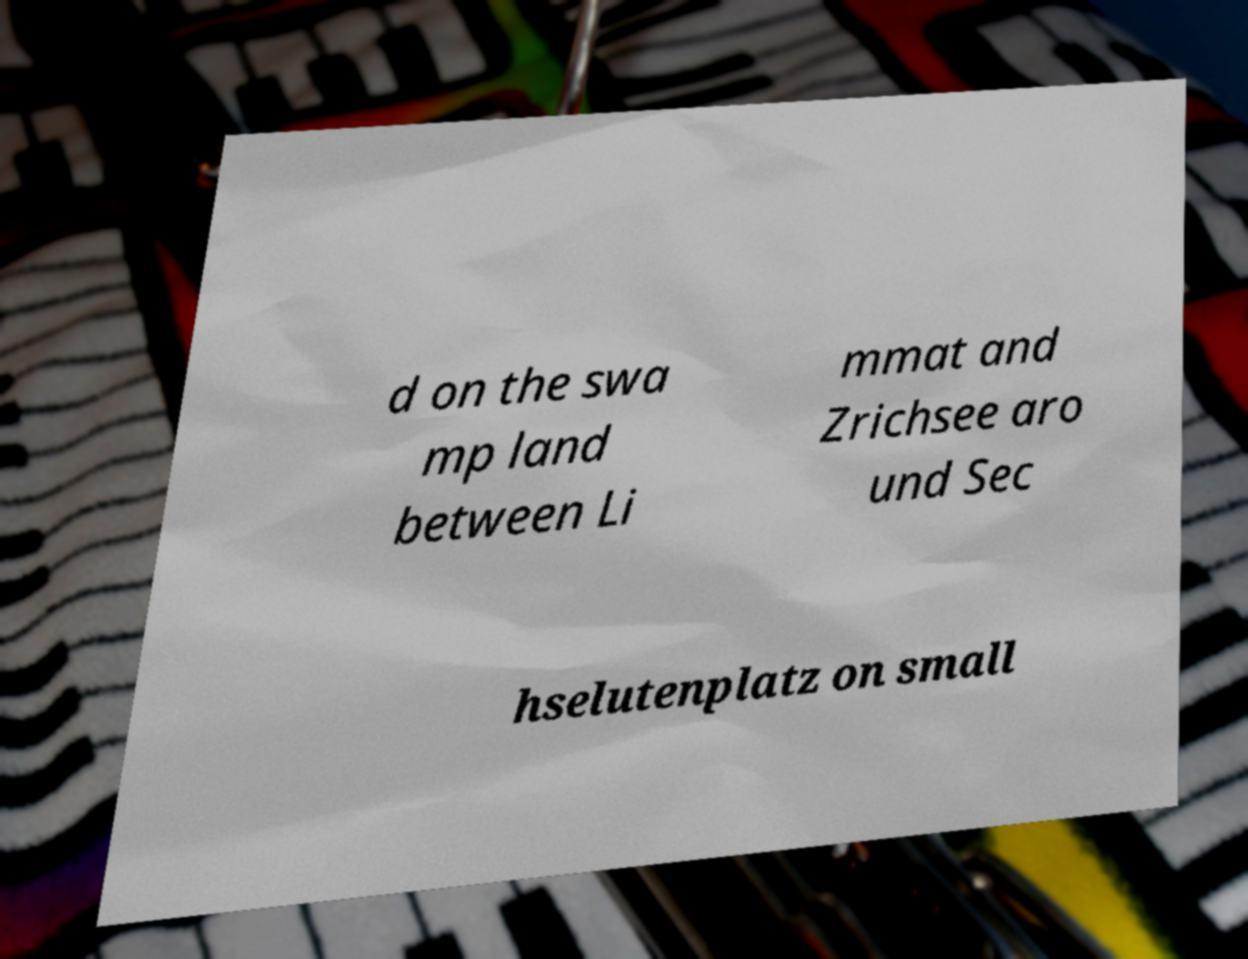There's text embedded in this image that I need extracted. Can you transcribe it verbatim? d on the swa mp land between Li mmat and Zrichsee aro und Sec hselutenplatz on small 